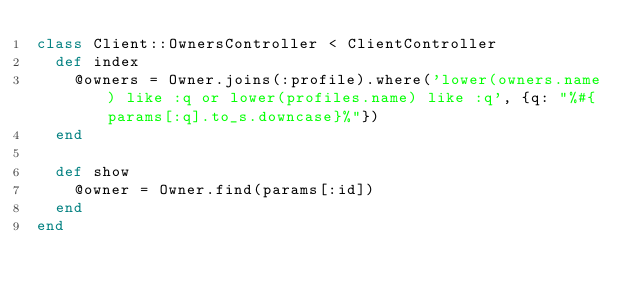<code> <loc_0><loc_0><loc_500><loc_500><_Ruby_>class Client::OwnersController < ClientController
  def index
    @owners = Owner.joins(:profile).where('lower(owners.name) like :q or lower(profiles.name) like :q', {q: "%#{params[:q].to_s.downcase}%"})
  end

  def show
    @owner = Owner.find(params[:id])
  end
end
</code> 